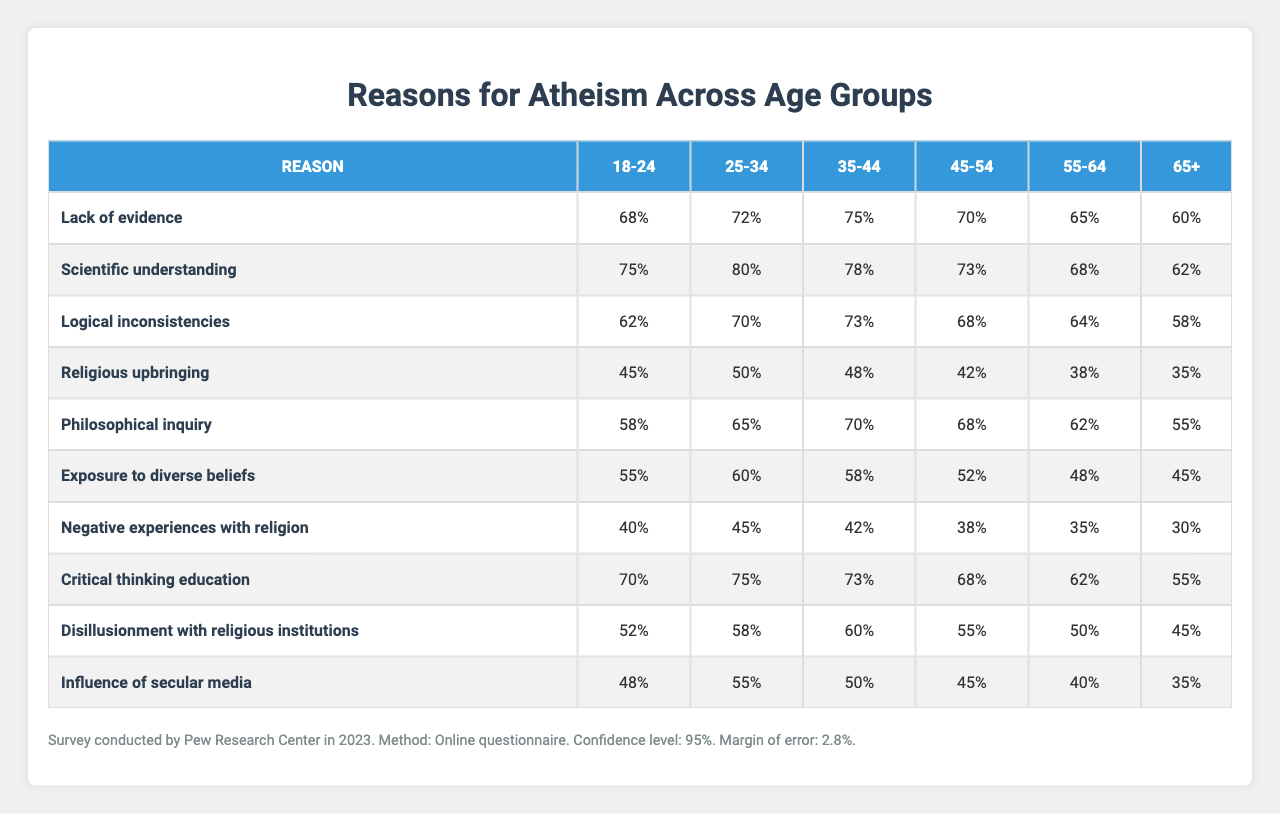What percentage of the 18-24 age group cited lack of evidence as a reason for atheism? The table shows that 68% of the 18-24 age group indicated lack of evidence as a reason for their atheism.
Answer: 68% Which age group showed the highest percentage for scientific understanding as a reason for atheism? Looking at the data, the 25-34 age group has the highest percentage at 80%.
Answer: 25-34 Is the percentage for negative experiences with religion higher in the 35-44 or the 45-54 age group? The 35-44 age group has a percentage of 42%, while the 45-54 age group has 38%. Hence, the 35-44 age group is higher.
Answer: 35-44 What is the average percentage of philosophical inquiry across all age groups? Adding the percentages for philosophical inquiry: (58 + 65 + 70 + 68 + 62 + 55) = 388. There are six age groups, so the average is 388 / 6 = 64.67, which rounds to 65%.
Answer: 65% Is there a noticeable trend in the percentage of disillusionment with religious institutions as age increases? Looking at the data, the percentage declines from 52% in the 18-24 age group to 45% in the 65+ age group, indicating a trend of decreasing disillusionment with age.
Answer: Yes What is the absolute difference between the percentages of exposure to diverse beliefs for the 18-24 and 55-64 age groups? The percentage for 18-24 is 55%, and for 55-64 it is 48%. The absolute difference is 55 - 48 = 7%.
Answer: 7% Summarize the two age groups with the lowest percentages for religious upbringing. The 55-64 age group has 38% and the 65+ age group has 35%, making these the two age groups with the lowest percentages for religious upbringing.
Answer: 55-64 and 65+ What percentage decrease in critical thinking education was observed from the 25-34 age group to the 65+ age group? The percentage for the 25-34 age group is 75%, and for the 65+ age group, it is 55%. The decrease is 75 - 55 = 20%.
Answer: 20% Which reason for atheism shows a decline across all age groups from the youngest to the oldest? The reasons show a trend of decline, specifically negative experiences with religion decreases from 40% in the 18-24 age group to 30% in the 65+ age group, indicating a consistent decrease.
Answer: Negative experiences with religion Calculate the total sample size for all age groups combined. Summing the sample sizes: 1200 + 1500 + 1350 + 1100 + 950 + 800 = 5400.
Answer: 5400 